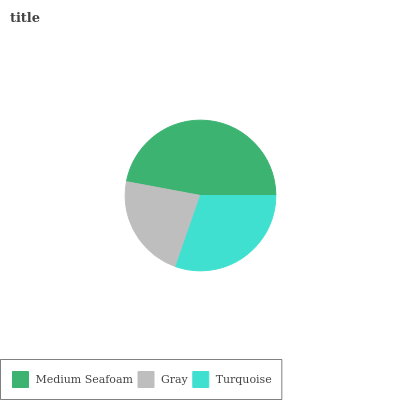Is Gray the minimum?
Answer yes or no. Yes. Is Medium Seafoam the maximum?
Answer yes or no. Yes. Is Turquoise the minimum?
Answer yes or no. No. Is Turquoise the maximum?
Answer yes or no. No. Is Turquoise greater than Gray?
Answer yes or no. Yes. Is Gray less than Turquoise?
Answer yes or no. Yes. Is Gray greater than Turquoise?
Answer yes or no. No. Is Turquoise less than Gray?
Answer yes or no. No. Is Turquoise the high median?
Answer yes or no. Yes. Is Turquoise the low median?
Answer yes or no. Yes. Is Medium Seafoam the high median?
Answer yes or no. No. Is Medium Seafoam the low median?
Answer yes or no. No. 